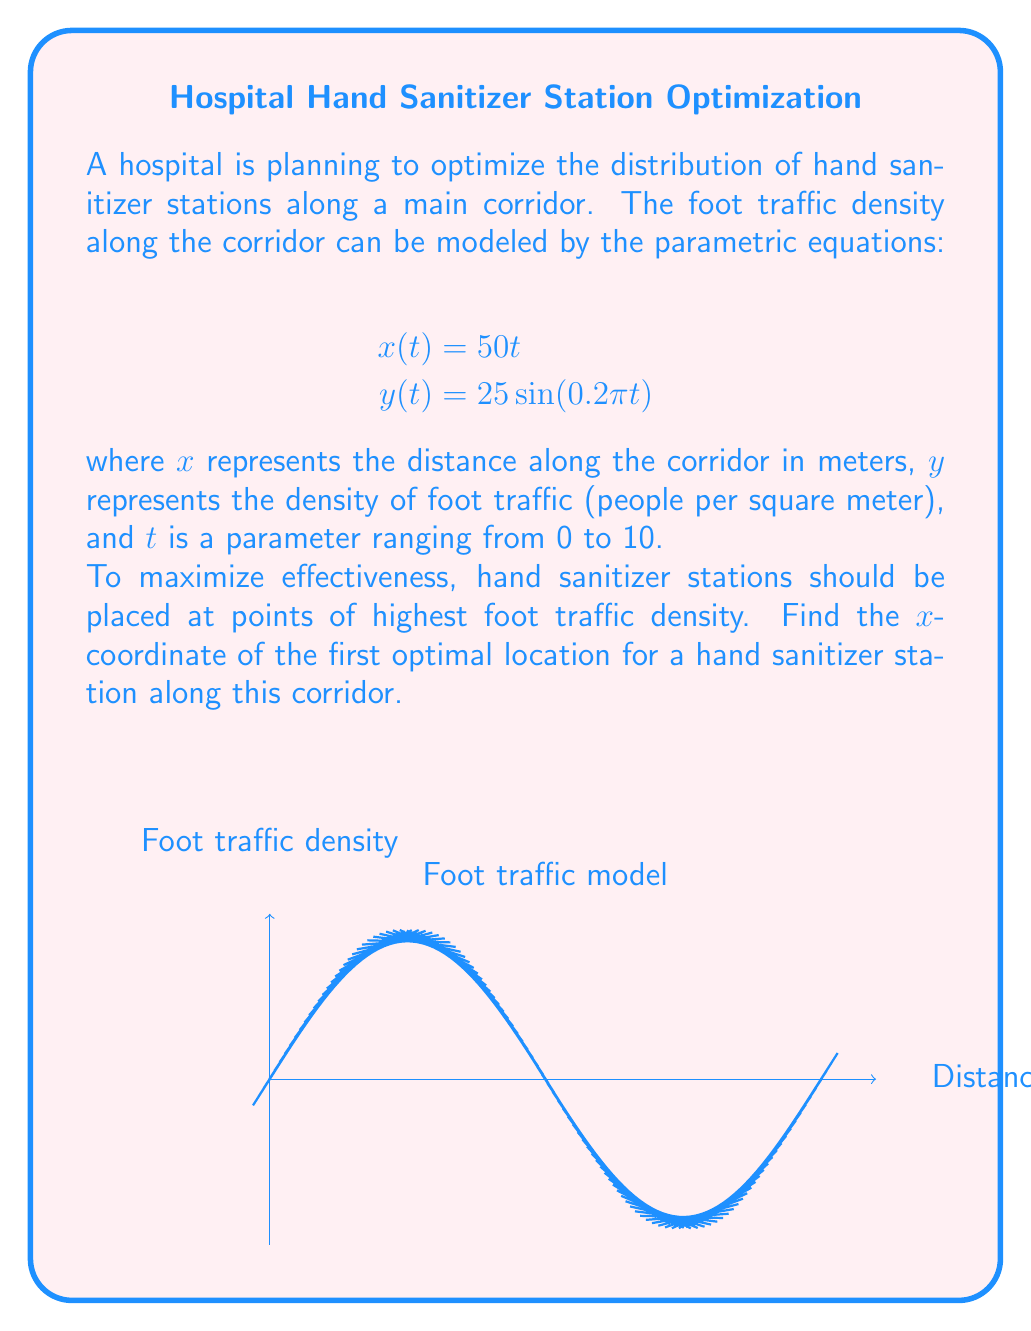Provide a solution to this math problem. To find the optimal location for the hand sanitizer station, we need to determine the point of maximum foot traffic density. This corresponds to finding the maximum value of $y(t)$ and its corresponding $x(t)$ value.

Step 1: Find the maximum of $y(t)$
The sine function reaches its maximum value of 1 when its argument is $\frac{\pi}{2} + 2\pi n$, where $n$ is an integer. So, we need to solve:

$$0.2\pi t = \frac{\pi}{2} + 2\pi n$$

Step 2: Solve for $t$
$$t = \frac{5}{2} + 10n$$

The first maximum occurs when $n = 0$, so $t = \frac{5}{2} = 2.5$

Step 3: Calculate the corresponding $x$-coordinate
Substitute $t = 2.5$ into the equation for $x(t)$:

$$x(2.5) = 50(2.5) = 125$$

Therefore, the first optimal location for a hand sanitizer station is 125 meters along the corridor.
Answer: 125 meters 